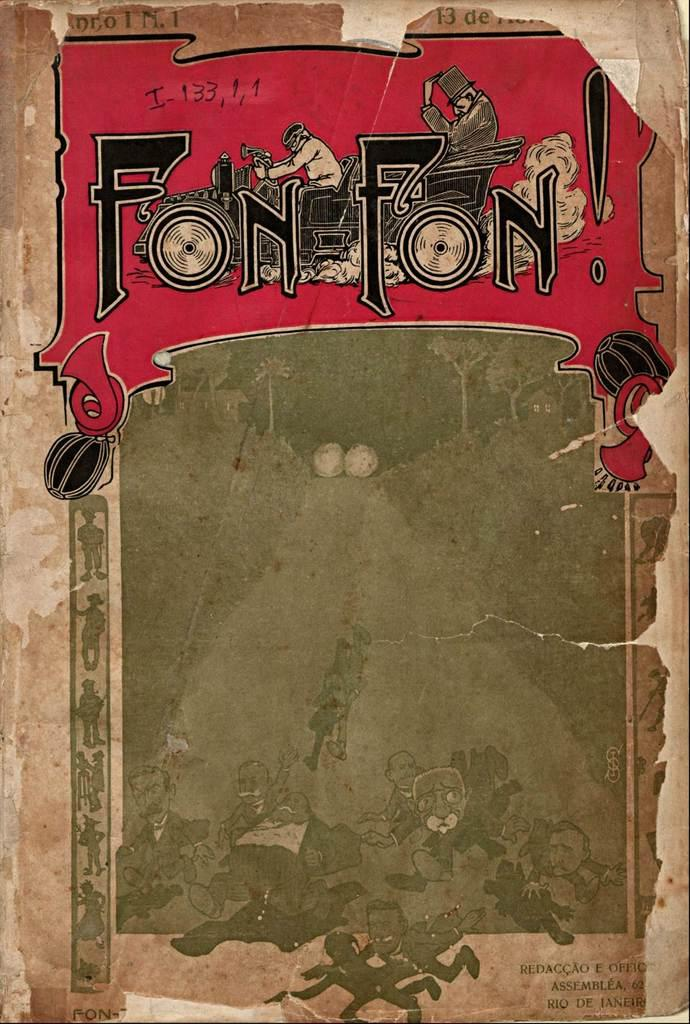<image>
Provide a brief description of the given image. A very old looking book which has the words Fon Fon across the top. 